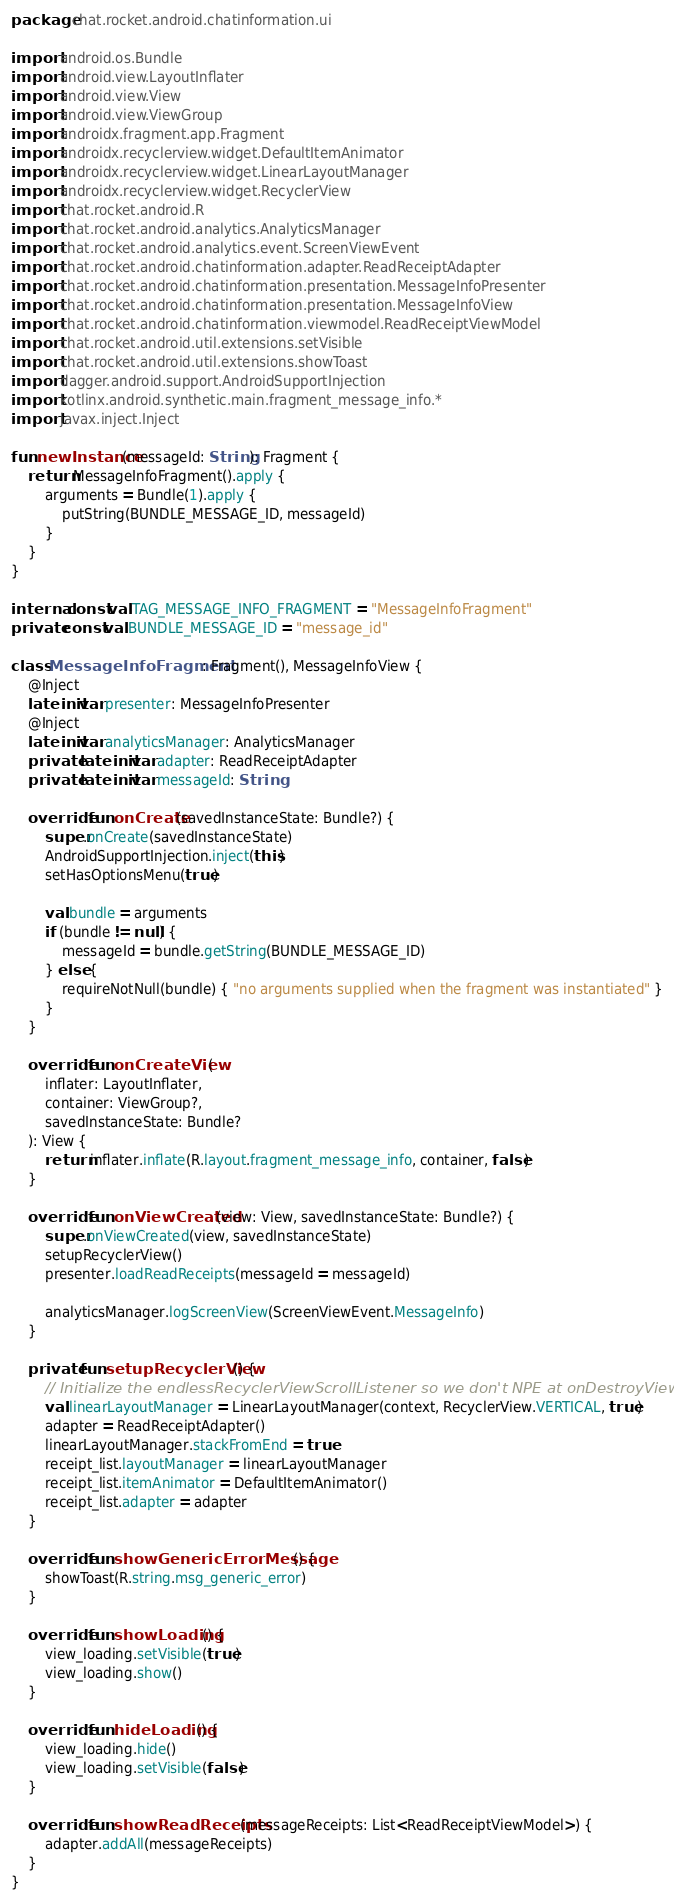<code> <loc_0><loc_0><loc_500><loc_500><_Kotlin_>package chat.rocket.android.chatinformation.ui

import android.os.Bundle
import android.view.LayoutInflater
import android.view.View
import android.view.ViewGroup
import androidx.fragment.app.Fragment
import androidx.recyclerview.widget.DefaultItemAnimator
import androidx.recyclerview.widget.LinearLayoutManager
import androidx.recyclerview.widget.RecyclerView
import chat.rocket.android.R
import chat.rocket.android.analytics.AnalyticsManager
import chat.rocket.android.analytics.event.ScreenViewEvent
import chat.rocket.android.chatinformation.adapter.ReadReceiptAdapter
import chat.rocket.android.chatinformation.presentation.MessageInfoPresenter
import chat.rocket.android.chatinformation.presentation.MessageInfoView
import chat.rocket.android.chatinformation.viewmodel.ReadReceiptViewModel
import chat.rocket.android.util.extensions.setVisible
import chat.rocket.android.util.extensions.showToast
import dagger.android.support.AndroidSupportInjection
import kotlinx.android.synthetic.main.fragment_message_info.*
import javax.inject.Inject

fun newInstance(messageId: String): Fragment {
    return MessageInfoFragment().apply {
        arguments = Bundle(1).apply {
            putString(BUNDLE_MESSAGE_ID, messageId)
        }
    }
}

internal const val TAG_MESSAGE_INFO_FRAGMENT = "MessageInfoFragment"
private const val BUNDLE_MESSAGE_ID = "message_id"

class MessageInfoFragment : Fragment(), MessageInfoView {
    @Inject
    lateinit var presenter: MessageInfoPresenter
    @Inject
    lateinit var analyticsManager: AnalyticsManager
    private lateinit var adapter: ReadReceiptAdapter
    private lateinit var messageId: String

    override fun onCreate(savedInstanceState: Bundle?) {
        super.onCreate(savedInstanceState)
        AndroidSupportInjection.inject(this)
        setHasOptionsMenu(true)

        val bundle = arguments
        if (bundle != null) {
            messageId = bundle.getString(BUNDLE_MESSAGE_ID)
        } else {
            requireNotNull(bundle) { "no arguments supplied when the fragment was instantiated" }
        }
    }

    override fun onCreateView(
        inflater: LayoutInflater,
        container: ViewGroup?,
        savedInstanceState: Bundle?
    ): View {
        return inflater.inflate(R.layout.fragment_message_info, container, false)
    }

    override fun onViewCreated(view: View, savedInstanceState: Bundle?) {
        super.onViewCreated(view, savedInstanceState)
        setupRecyclerView()
        presenter.loadReadReceipts(messageId = messageId)

        analyticsManager.logScreenView(ScreenViewEvent.MessageInfo)
    }

    private fun setupRecyclerView() {
        // Initialize the endlessRecyclerViewScrollListener so we don't NPE at onDestroyView
        val linearLayoutManager = LinearLayoutManager(context, RecyclerView.VERTICAL, true)
        adapter = ReadReceiptAdapter()
        linearLayoutManager.stackFromEnd = true
        receipt_list.layoutManager = linearLayoutManager
        receipt_list.itemAnimator = DefaultItemAnimator()
        receipt_list.adapter = adapter
    }

    override fun showGenericErrorMessage() {
        showToast(R.string.msg_generic_error)
    }

    override fun showLoading() {
        view_loading.setVisible(true)
        view_loading.show()
    }

    override fun hideLoading() {
        view_loading.hide()
        view_loading.setVisible(false)
    }

    override fun showReadReceipts(messageReceipts: List<ReadReceiptViewModel>) {
        adapter.addAll(messageReceipts)
    }
}
</code> 